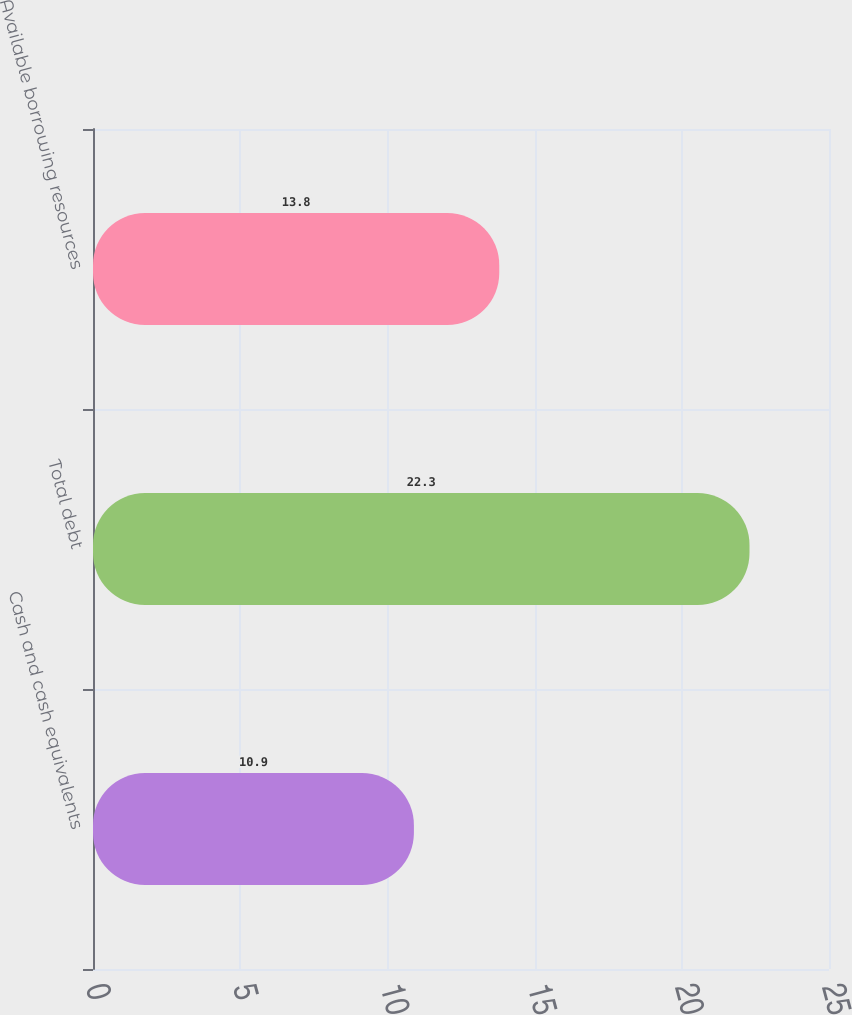Convert chart to OTSL. <chart><loc_0><loc_0><loc_500><loc_500><bar_chart><fcel>Cash and cash equivalents<fcel>Total debt<fcel>Available borrowing resources<nl><fcel>10.9<fcel>22.3<fcel>13.8<nl></chart> 